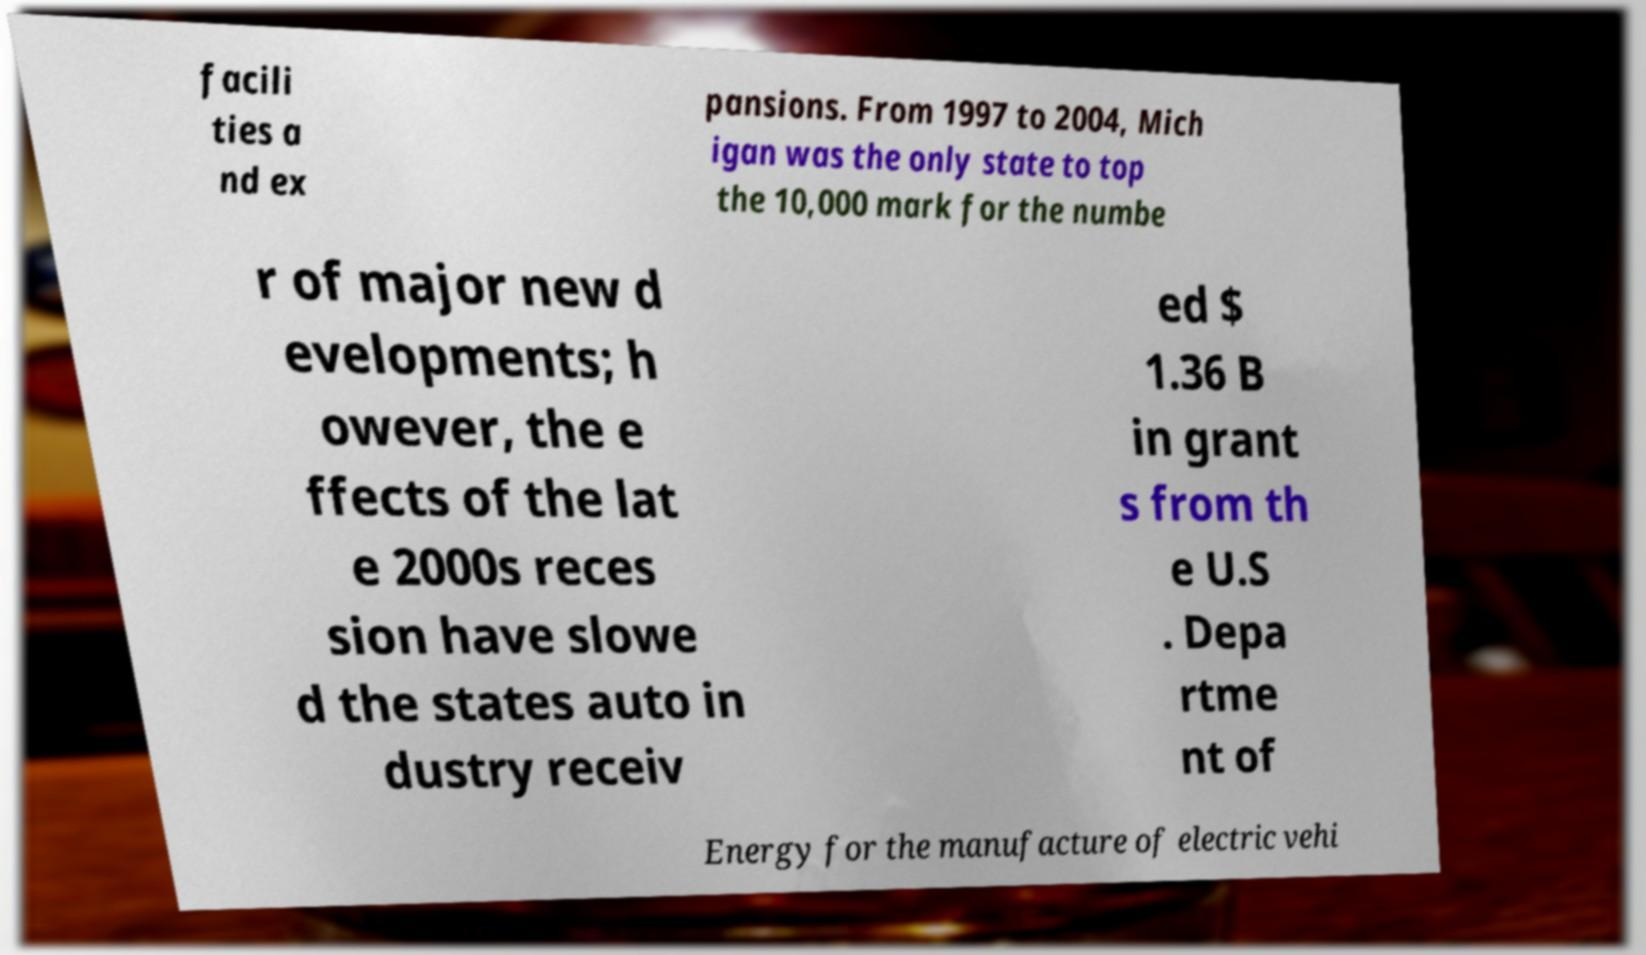Please identify and transcribe the text found in this image. facili ties a nd ex pansions. From 1997 to 2004, Mich igan was the only state to top the 10,000 mark for the numbe r of major new d evelopments; h owever, the e ffects of the lat e 2000s reces sion have slowe d the states auto in dustry receiv ed $ 1.36 B in grant s from th e U.S . Depa rtme nt of Energy for the manufacture of electric vehi 